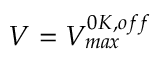Convert formula to latex. <formula><loc_0><loc_0><loc_500><loc_500>V = V _ { \max } ^ { 0 K , o f f }</formula> 